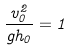Convert formula to latex. <formula><loc_0><loc_0><loc_500><loc_500>\frac { v _ { 0 } ^ { 2 } } { g h _ { 0 } } = 1</formula> 